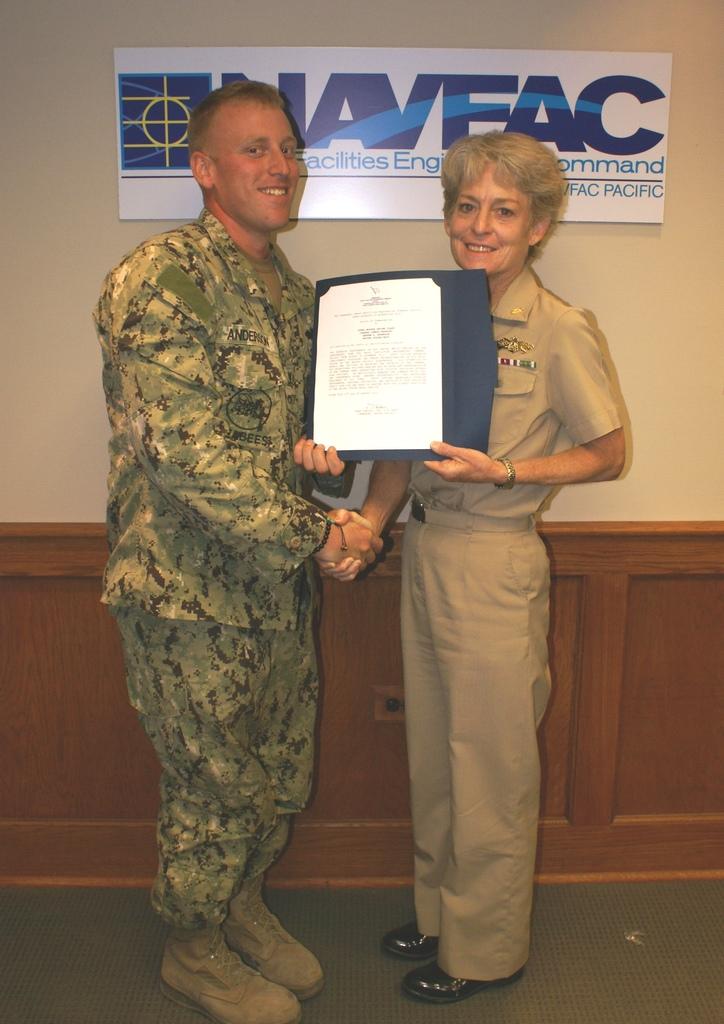What is the acronym used on the sign behind the two people?
Provide a succinct answer. Naveac. What is the bottom right word on the sign in the back?
Provide a short and direct response. Pacific. 